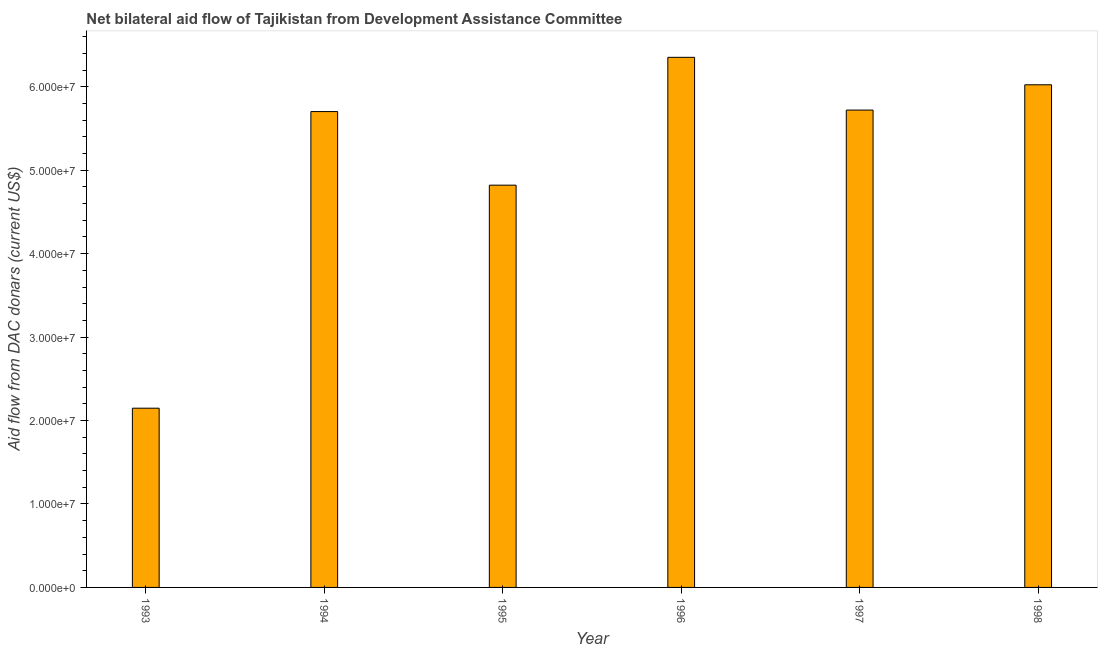Does the graph contain grids?
Provide a succinct answer. No. What is the title of the graph?
Provide a succinct answer. Net bilateral aid flow of Tajikistan from Development Assistance Committee. What is the label or title of the Y-axis?
Offer a terse response. Aid flow from DAC donars (current US$). What is the net bilateral aid flows from dac donors in 1998?
Provide a succinct answer. 6.02e+07. Across all years, what is the maximum net bilateral aid flows from dac donors?
Give a very brief answer. 6.35e+07. Across all years, what is the minimum net bilateral aid flows from dac donors?
Keep it short and to the point. 2.15e+07. In which year was the net bilateral aid flows from dac donors minimum?
Your answer should be compact. 1993. What is the sum of the net bilateral aid flows from dac donors?
Your answer should be compact. 3.08e+08. What is the difference between the net bilateral aid flows from dac donors in 1993 and 1994?
Your answer should be compact. -3.56e+07. What is the average net bilateral aid flows from dac donors per year?
Your answer should be compact. 5.13e+07. What is the median net bilateral aid flows from dac donors?
Your answer should be very brief. 5.71e+07. Is the net bilateral aid flows from dac donors in 1995 less than that in 1998?
Provide a succinct answer. Yes. Is the difference between the net bilateral aid flows from dac donors in 1995 and 1998 greater than the difference between any two years?
Offer a terse response. No. What is the difference between the highest and the second highest net bilateral aid flows from dac donors?
Provide a succinct answer. 3.29e+06. What is the difference between the highest and the lowest net bilateral aid flows from dac donors?
Provide a short and direct response. 4.20e+07. In how many years, is the net bilateral aid flows from dac donors greater than the average net bilateral aid flows from dac donors taken over all years?
Offer a terse response. 4. How many years are there in the graph?
Provide a succinct answer. 6. Are the values on the major ticks of Y-axis written in scientific E-notation?
Your answer should be very brief. Yes. What is the Aid flow from DAC donars (current US$) in 1993?
Offer a terse response. 2.15e+07. What is the Aid flow from DAC donars (current US$) of 1994?
Ensure brevity in your answer.  5.70e+07. What is the Aid flow from DAC donars (current US$) of 1995?
Your response must be concise. 4.82e+07. What is the Aid flow from DAC donars (current US$) of 1996?
Give a very brief answer. 6.35e+07. What is the Aid flow from DAC donars (current US$) of 1997?
Offer a very short reply. 5.72e+07. What is the Aid flow from DAC donars (current US$) of 1998?
Give a very brief answer. 6.02e+07. What is the difference between the Aid flow from DAC donars (current US$) in 1993 and 1994?
Give a very brief answer. -3.56e+07. What is the difference between the Aid flow from DAC donars (current US$) in 1993 and 1995?
Your response must be concise. -2.67e+07. What is the difference between the Aid flow from DAC donars (current US$) in 1993 and 1996?
Offer a terse response. -4.20e+07. What is the difference between the Aid flow from DAC donars (current US$) in 1993 and 1997?
Give a very brief answer. -3.57e+07. What is the difference between the Aid flow from DAC donars (current US$) in 1993 and 1998?
Give a very brief answer. -3.88e+07. What is the difference between the Aid flow from DAC donars (current US$) in 1994 and 1995?
Give a very brief answer. 8.82e+06. What is the difference between the Aid flow from DAC donars (current US$) in 1994 and 1996?
Make the answer very short. -6.50e+06. What is the difference between the Aid flow from DAC donars (current US$) in 1994 and 1997?
Give a very brief answer. -1.80e+05. What is the difference between the Aid flow from DAC donars (current US$) in 1994 and 1998?
Offer a terse response. -3.21e+06. What is the difference between the Aid flow from DAC donars (current US$) in 1995 and 1996?
Give a very brief answer. -1.53e+07. What is the difference between the Aid flow from DAC donars (current US$) in 1995 and 1997?
Make the answer very short. -9.00e+06. What is the difference between the Aid flow from DAC donars (current US$) in 1995 and 1998?
Your response must be concise. -1.20e+07. What is the difference between the Aid flow from DAC donars (current US$) in 1996 and 1997?
Your answer should be very brief. 6.32e+06. What is the difference between the Aid flow from DAC donars (current US$) in 1996 and 1998?
Make the answer very short. 3.29e+06. What is the difference between the Aid flow from DAC donars (current US$) in 1997 and 1998?
Your answer should be very brief. -3.03e+06. What is the ratio of the Aid flow from DAC donars (current US$) in 1993 to that in 1994?
Your answer should be compact. 0.38. What is the ratio of the Aid flow from DAC donars (current US$) in 1993 to that in 1995?
Ensure brevity in your answer.  0.45. What is the ratio of the Aid flow from DAC donars (current US$) in 1993 to that in 1996?
Keep it short and to the point. 0.34. What is the ratio of the Aid flow from DAC donars (current US$) in 1993 to that in 1998?
Your response must be concise. 0.36. What is the ratio of the Aid flow from DAC donars (current US$) in 1994 to that in 1995?
Provide a succinct answer. 1.18. What is the ratio of the Aid flow from DAC donars (current US$) in 1994 to that in 1996?
Provide a succinct answer. 0.9. What is the ratio of the Aid flow from DAC donars (current US$) in 1994 to that in 1997?
Keep it short and to the point. 1. What is the ratio of the Aid flow from DAC donars (current US$) in 1994 to that in 1998?
Your response must be concise. 0.95. What is the ratio of the Aid flow from DAC donars (current US$) in 1995 to that in 1996?
Provide a succinct answer. 0.76. What is the ratio of the Aid flow from DAC donars (current US$) in 1995 to that in 1997?
Provide a succinct answer. 0.84. What is the ratio of the Aid flow from DAC donars (current US$) in 1996 to that in 1997?
Offer a very short reply. 1.11. What is the ratio of the Aid flow from DAC donars (current US$) in 1996 to that in 1998?
Your response must be concise. 1.05. 